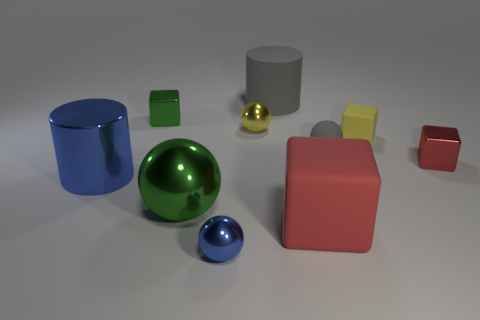The tiny sphere that is made of the same material as the tiny blue object is what color?
Your answer should be very brief. Yellow. What number of green balls have the same size as the gray matte cylinder?
Ensure brevity in your answer.  1. What is the material of the large red thing?
Provide a succinct answer. Rubber. Is the number of cyan matte balls greater than the number of blue metal cylinders?
Keep it short and to the point. No. Is the shape of the tiny gray thing the same as the tiny yellow rubber object?
Provide a short and direct response. No. Are there any other things that have the same shape as the yellow rubber object?
Ensure brevity in your answer.  Yes. Does the block that is in front of the large blue metallic object have the same color as the tiny shiny block that is to the right of the tiny gray rubber thing?
Your answer should be very brief. Yes. Are there fewer tiny yellow shiny balls that are left of the blue shiny sphere than green objects in front of the matte cylinder?
Your answer should be compact. Yes. There is a large matte thing right of the rubber cylinder; what shape is it?
Ensure brevity in your answer.  Cube. There is a ball that is the same color as the matte cylinder; what material is it?
Ensure brevity in your answer.  Rubber. 